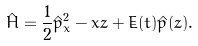Convert formula to latex. <formula><loc_0><loc_0><loc_500><loc_500>\hat { H } = \frac { 1 } { 2 } \hat { p } _ { x } ^ { 2 } - x z + \dot { E } ( t ) \hat { p } ( z ) .</formula> 